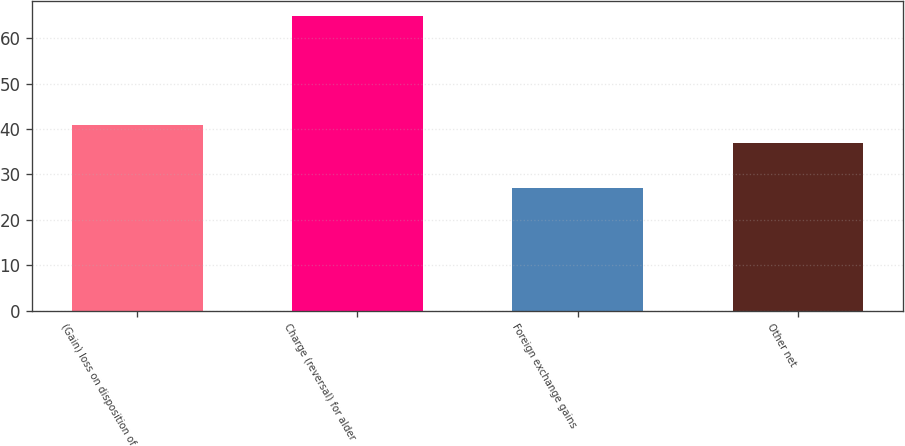Convert chart to OTSL. <chart><loc_0><loc_0><loc_500><loc_500><bar_chart><fcel>(Gain) loss on disposition of<fcel>Charge (reversal) for alder<fcel>Foreign exchange gains<fcel>Other net<nl><fcel>40.8<fcel>65<fcel>27<fcel>37<nl></chart> 